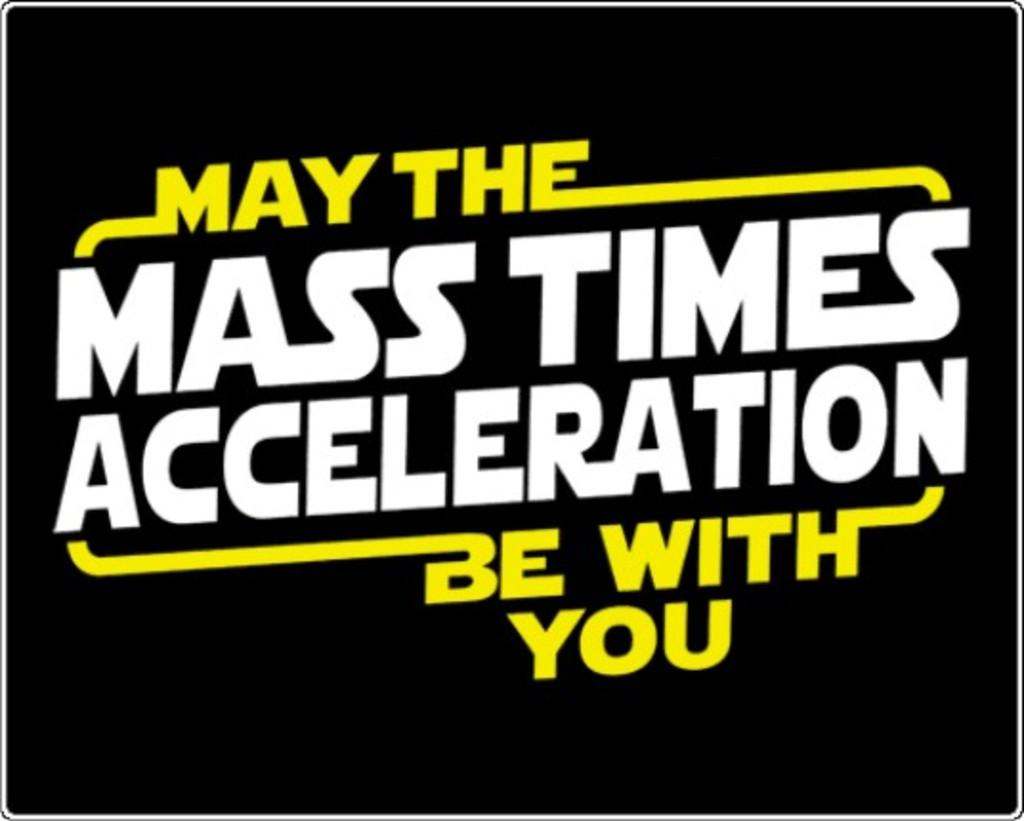What kind of acceleration should be with you?
Offer a terse response. Mass times. Who should the mass time acceleration be with?
Ensure brevity in your answer.  You. 